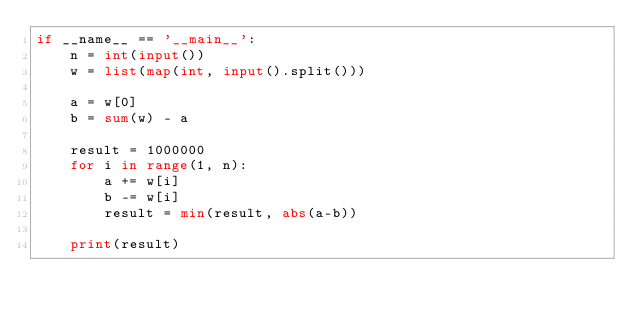Convert code to text. <code><loc_0><loc_0><loc_500><loc_500><_Python_>if __name__ == '__main__':
    n = int(input())
    w = list(map(int, input().split()))

    a = w[0]
    b = sum(w) - a

    result = 1000000
    for i in range(1, n):
        a += w[i]
        b -= w[i]
        result = min(result, abs(a-b))

    print(result)
</code> 